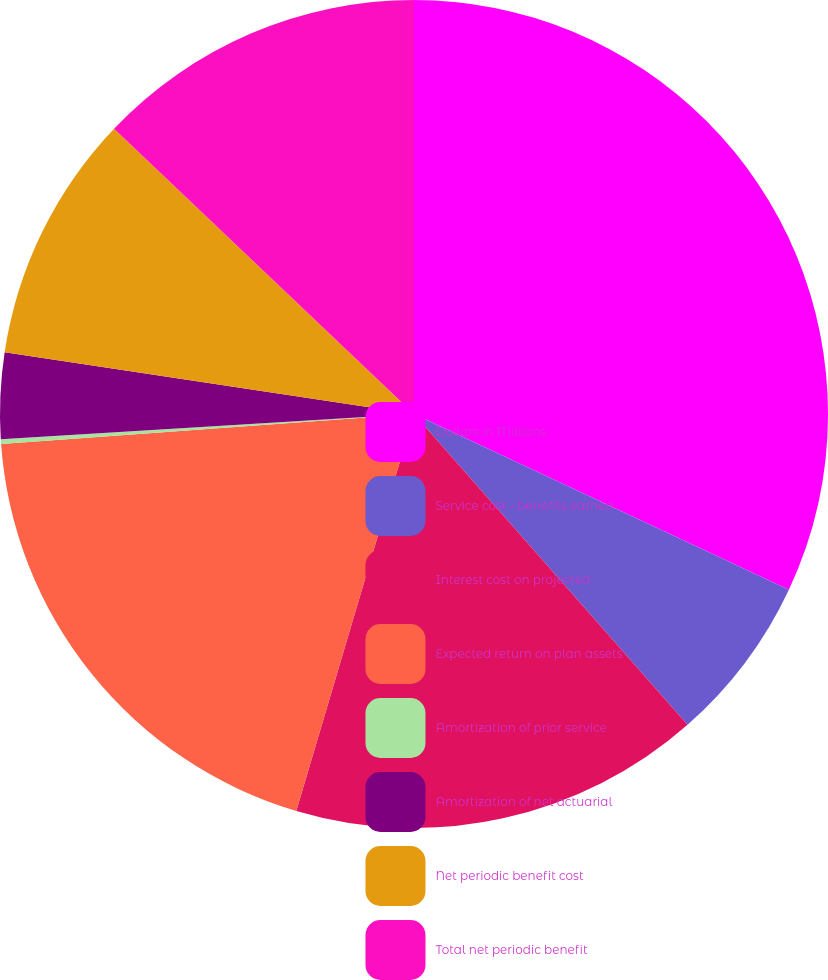Convert chart to OTSL. <chart><loc_0><loc_0><loc_500><loc_500><pie_chart><fcel>Dollars in Millions<fcel>Service cost - benefits earned<fcel>Interest cost on projected<fcel>Expected return on plan assets<fcel>Amortization of prior service<fcel>Amortization of net actuarial<fcel>Net periodic benefit cost<fcel>Total net periodic benefit<nl><fcel>31.98%<fcel>6.54%<fcel>16.08%<fcel>19.26%<fcel>0.18%<fcel>3.36%<fcel>9.72%<fcel>12.9%<nl></chart> 